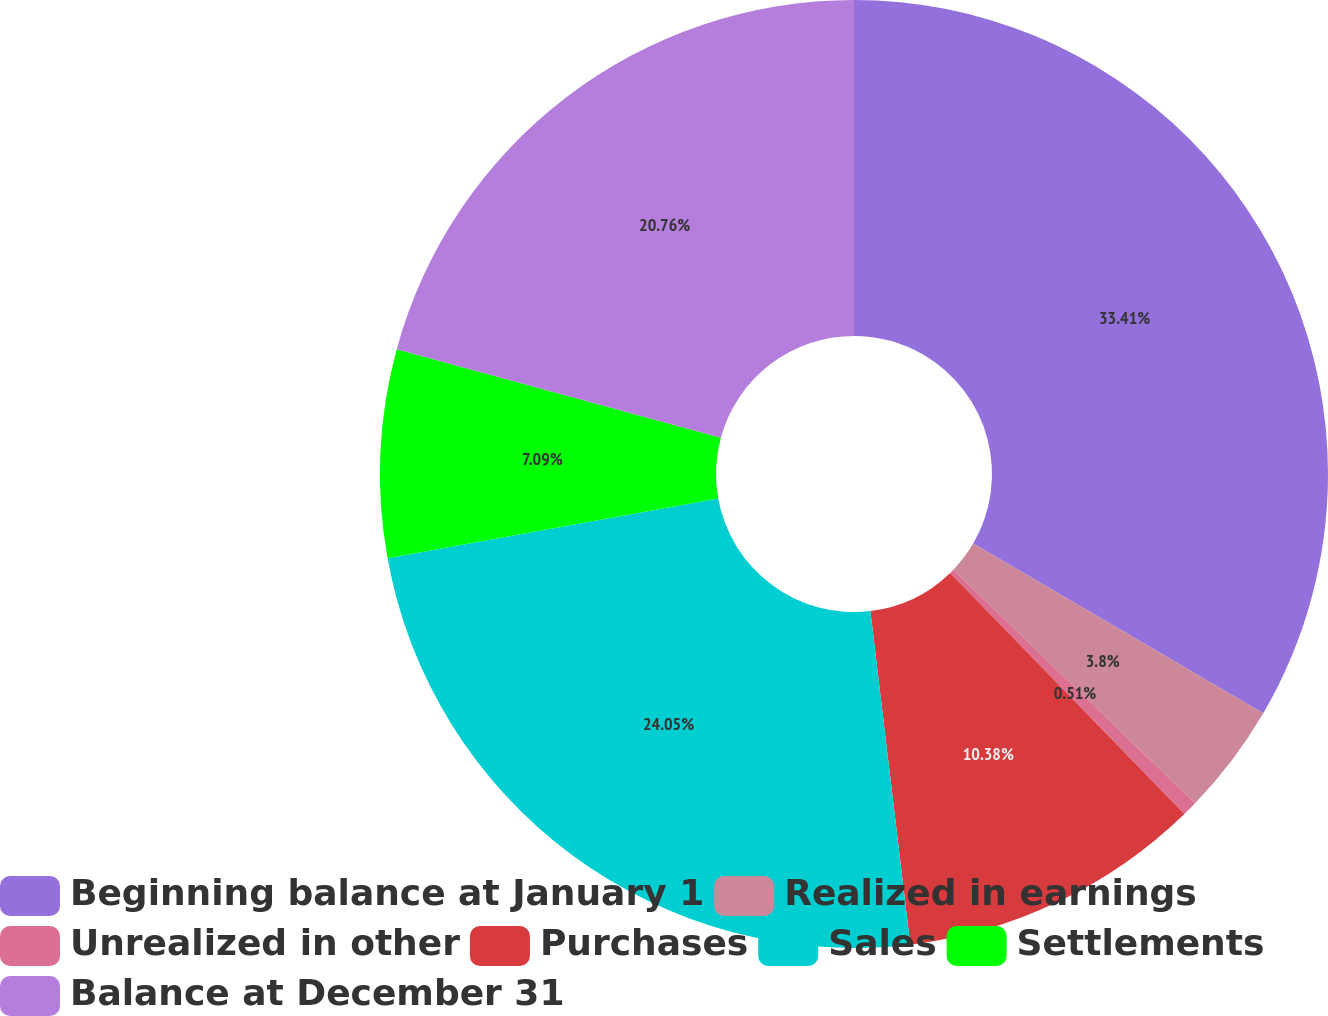Convert chart. <chart><loc_0><loc_0><loc_500><loc_500><pie_chart><fcel>Beginning balance at January 1<fcel>Realized in earnings<fcel>Unrealized in other<fcel>Purchases<fcel>Sales<fcel>Settlements<fcel>Balance at December 31<nl><fcel>33.42%<fcel>3.8%<fcel>0.51%<fcel>10.38%<fcel>24.05%<fcel>7.09%<fcel>20.76%<nl></chart> 